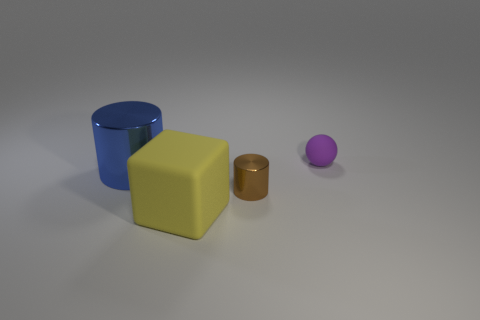Are any tiny metal things visible?
Keep it short and to the point. Yes. The rubber thing that is to the right of the small thing that is in front of the small purple ball is what color?
Give a very brief answer. Purple. How many objects are either tiny purple balls or things that are in front of the small purple rubber object?
Keep it short and to the point. 4. What color is the metal cylinder that is on the right side of the blue object?
Provide a short and direct response. Brown. What is the shape of the big blue object?
Make the answer very short. Cylinder. What material is the tiny thing that is to the left of the rubber object right of the yellow thing?
Make the answer very short. Metal. There is a thing that is the same size as the blue metallic cylinder; what material is it?
Give a very brief answer. Rubber. Is the number of brown shiny things that are on the right side of the small rubber object greater than the number of blue things that are behind the tiny brown cylinder?
Offer a very short reply. No. Are there any other big rubber objects that have the same shape as the blue thing?
Give a very brief answer. No. What shape is the brown metallic thing that is the same size as the purple ball?
Offer a terse response. Cylinder. 